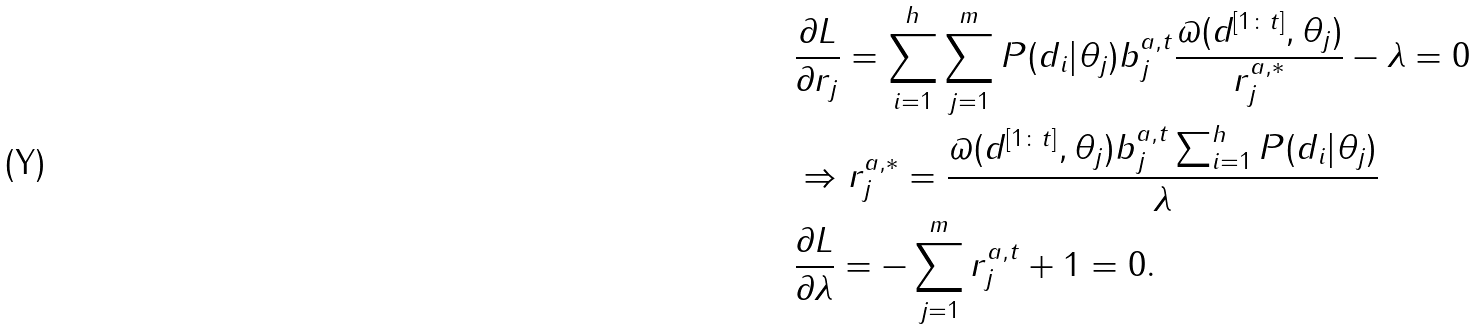Convert formula to latex. <formula><loc_0><loc_0><loc_500><loc_500>& \frac { \partial L } { \partial r _ { j } } = \sum _ { i = 1 } ^ { h } \sum _ { j = 1 } ^ { m } P ( d _ { i } | \theta _ { j } ) b _ { j } ^ { a , t } \frac { \varpi ( d ^ { [ 1 \colon t ] } , \theta _ { j } ) } { r _ { j } ^ { a , * } } - \lambda = 0 \\ & \Rightarrow r _ { j } ^ { a , * } = \frac { \varpi ( d ^ { [ 1 \colon t ] } , \theta _ { j } ) b _ { j } ^ { a , t } \sum _ { i = 1 } ^ { h } P ( d _ { i } | \theta _ { j } ) } { \lambda } \\ & \frac { \partial L } { \partial \lambda } = - \sum _ { j = 1 } ^ { m } r _ { j } ^ { a , t } + 1 = 0 . \\</formula> 